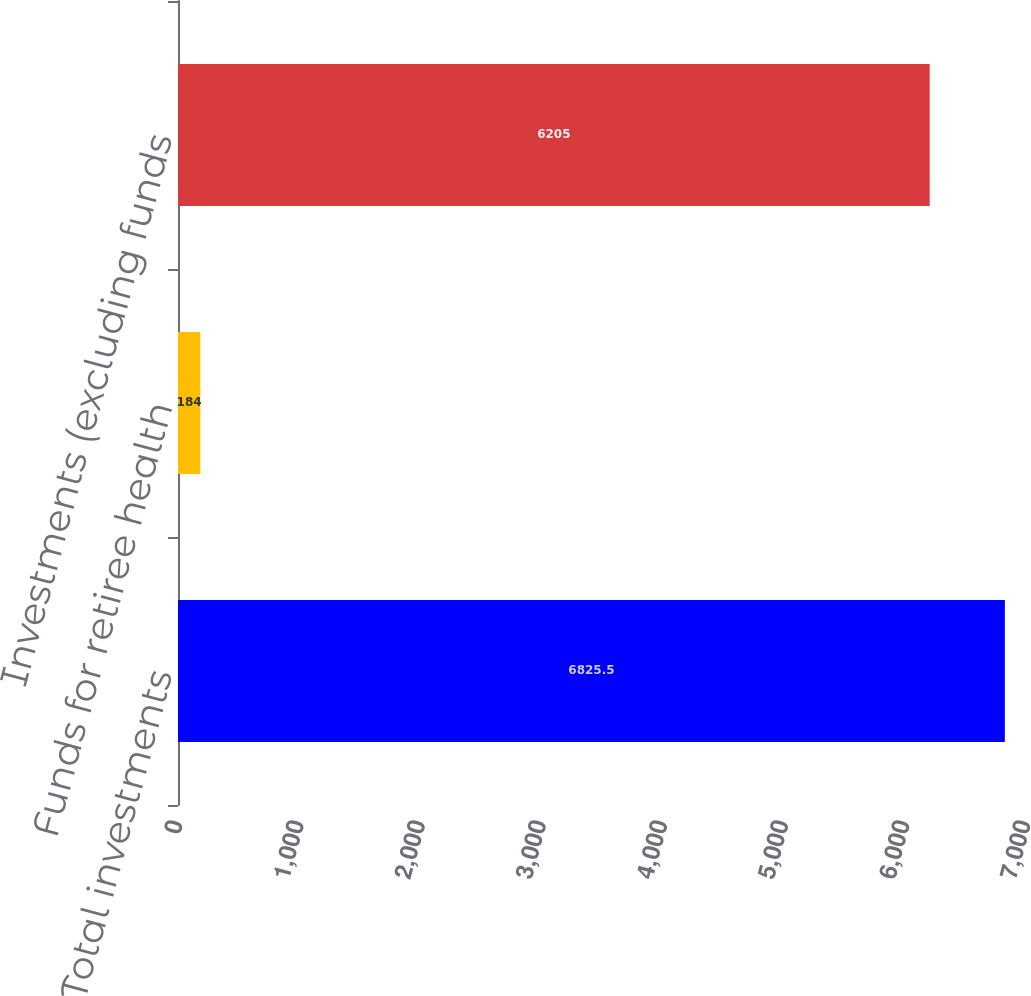Convert chart to OTSL. <chart><loc_0><loc_0><loc_500><loc_500><bar_chart><fcel>Total investments<fcel>Funds for retiree health<fcel>Investments (excluding funds<nl><fcel>6825.5<fcel>184<fcel>6205<nl></chart> 